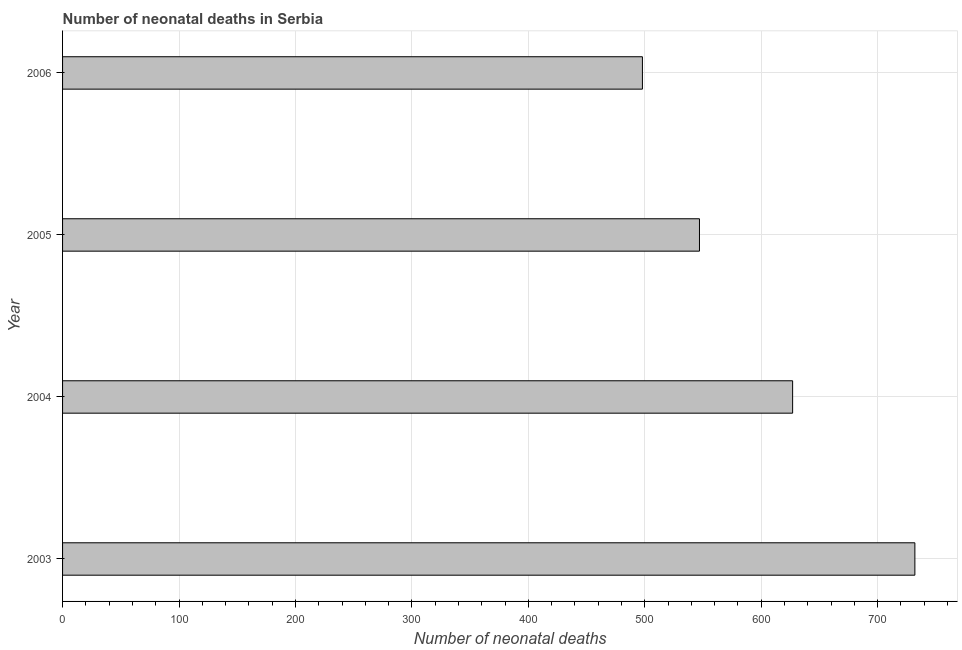Does the graph contain grids?
Your response must be concise. Yes. What is the title of the graph?
Offer a terse response. Number of neonatal deaths in Serbia. What is the label or title of the X-axis?
Your response must be concise. Number of neonatal deaths. What is the number of neonatal deaths in 2003?
Ensure brevity in your answer.  732. Across all years, what is the maximum number of neonatal deaths?
Provide a succinct answer. 732. Across all years, what is the minimum number of neonatal deaths?
Make the answer very short. 498. In which year was the number of neonatal deaths maximum?
Your response must be concise. 2003. In which year was the number of neonatal deaths minimum?
Your response must be concise. 2006. What is the sum of the number of neonatal deaths?
Your answer should be compact. 2404. What is the difference between the number of neonatal deaths in 2004 and 2006?
Make the answer very short. 129. What is the average number of neonatal deaths per year?
Provide a succinct answer. 601. What is the median number of neonatal deaths?
Provide a short and direct response. 587. In how many years, is the number of neonatal deaths greater than 380 ?
Make the answer very short. 4. Do a majority of the years between 2004 and 2005 (inclusive) have number of neonatal deaths greater than 620 ?
Provide a succinct answer. No. What is the ratio of the number of neonatal deaths in 2004 to that in 2005?
Your response must be concise. 1.15. What is the difference between the highest and the second highest number of neonatal deaths?
Offer a very short reply. 105. Is the sum of the number of neonatal deaths in 2005 and 2006 greater than the maximum number of neonatal deaths across all years?
Offer a very short reply. Yes. What is the difference between the highest and the lowest number of neonatal deaths?
Your answer should be very brief. 234. In how many years, is the number of neonatal deaths greater than the average number of neonatal deaths taken over all years?
Keep it short and to the point. 2. How many bars are there?
Offer a very short reply. 4. Are the values on the major ticks of X-axis written in scientific E-notation?
Your answer should be very brief. No. What is the Number of neonatal deaths in 2003?
Keep it short and to the point. 732. What is the Number of neonatal deaths of 2004?
Give a very brief answer. 627. What is the Number of neonatal deaths of 2005?
Ensure brevity in your answer.  547. What is the Number of neonatal deaths in 2006?
Your response must be concise. 498. What is the difference between the Number of neonatal deaths in 2003 and 2004?
Your response must be concise. 105. What is the difference between the Number of neonatal deaths in 2003 and 2005?
Offer a very short reply. 185. What is the difference between the Number of neonatal deaths in 2003 and 2006?
Your answer should be compact. 234. What is the difference between the Number of neonatal deaths in 2004 and 2005?
Offer a terse response. 80. What is the difference between the Number of neonatal deaths in 2004 and 2006?
Ensure brevity in your answer.  129. What is the difference between the Number of neonatal deaths in 2005 and 2006?
Provide a short and direct response. 49. What is the ratio of the Number of neonatal deaths in 2003 to that in 2004?
Your response must be concise. 1.17. What is the ratio of the Number of neonatal deaths in 2003 to that in 2005?
Ensure brevity in your answer.  1.34. What is the ratio of the Number of neonatal deaths in 2003 to that in 2006?
Offer a terse response. 1.47. What is the ratio of the Number of neonatal deaths in 2004 to that in 2005?
Provide a succinct answer. 1.15. What is the ratio of the Number of neonatal deaths in 2004 to that in 2006?
Provide a succinct answer. 1.26. What is the ratio of the Number of neonatal deaths in 2005 to that in 2006?
Ensure brevity in your answer.  1.1. 